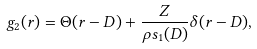Convert formula to latex. <formula><loc_0><loc_0><loc_500><loc_500>g _ { 2 } ( r ) = \Theta ( r - D ) + \frac { Z } { \rho s _ { 1 } ( D ) } \delta ( r - D ) ,</formula> 